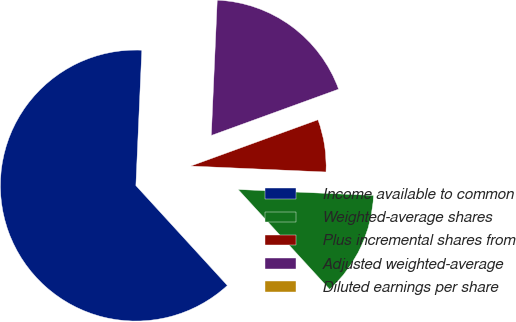Convert chart to OTSL. <chart><loc_0><loc_0><loc_500><loc_500><pie_chart><fcel>Income available to common<fcel>Weighted-average shares<fcel>Plus incremental shares from<fcel>Adjusted weighted-average<fcel>Diluted earnings per share<nl><fcel>62.5%<fcel>12.5%<fcel>6.25%<fcel>18.75%<fcel>0.0%<nl></chart> 